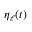Convert formula to latex. <formula><loc_0><loc_0><loc_500><loc_500>\eta _ { \ell } ( t )</formula> 